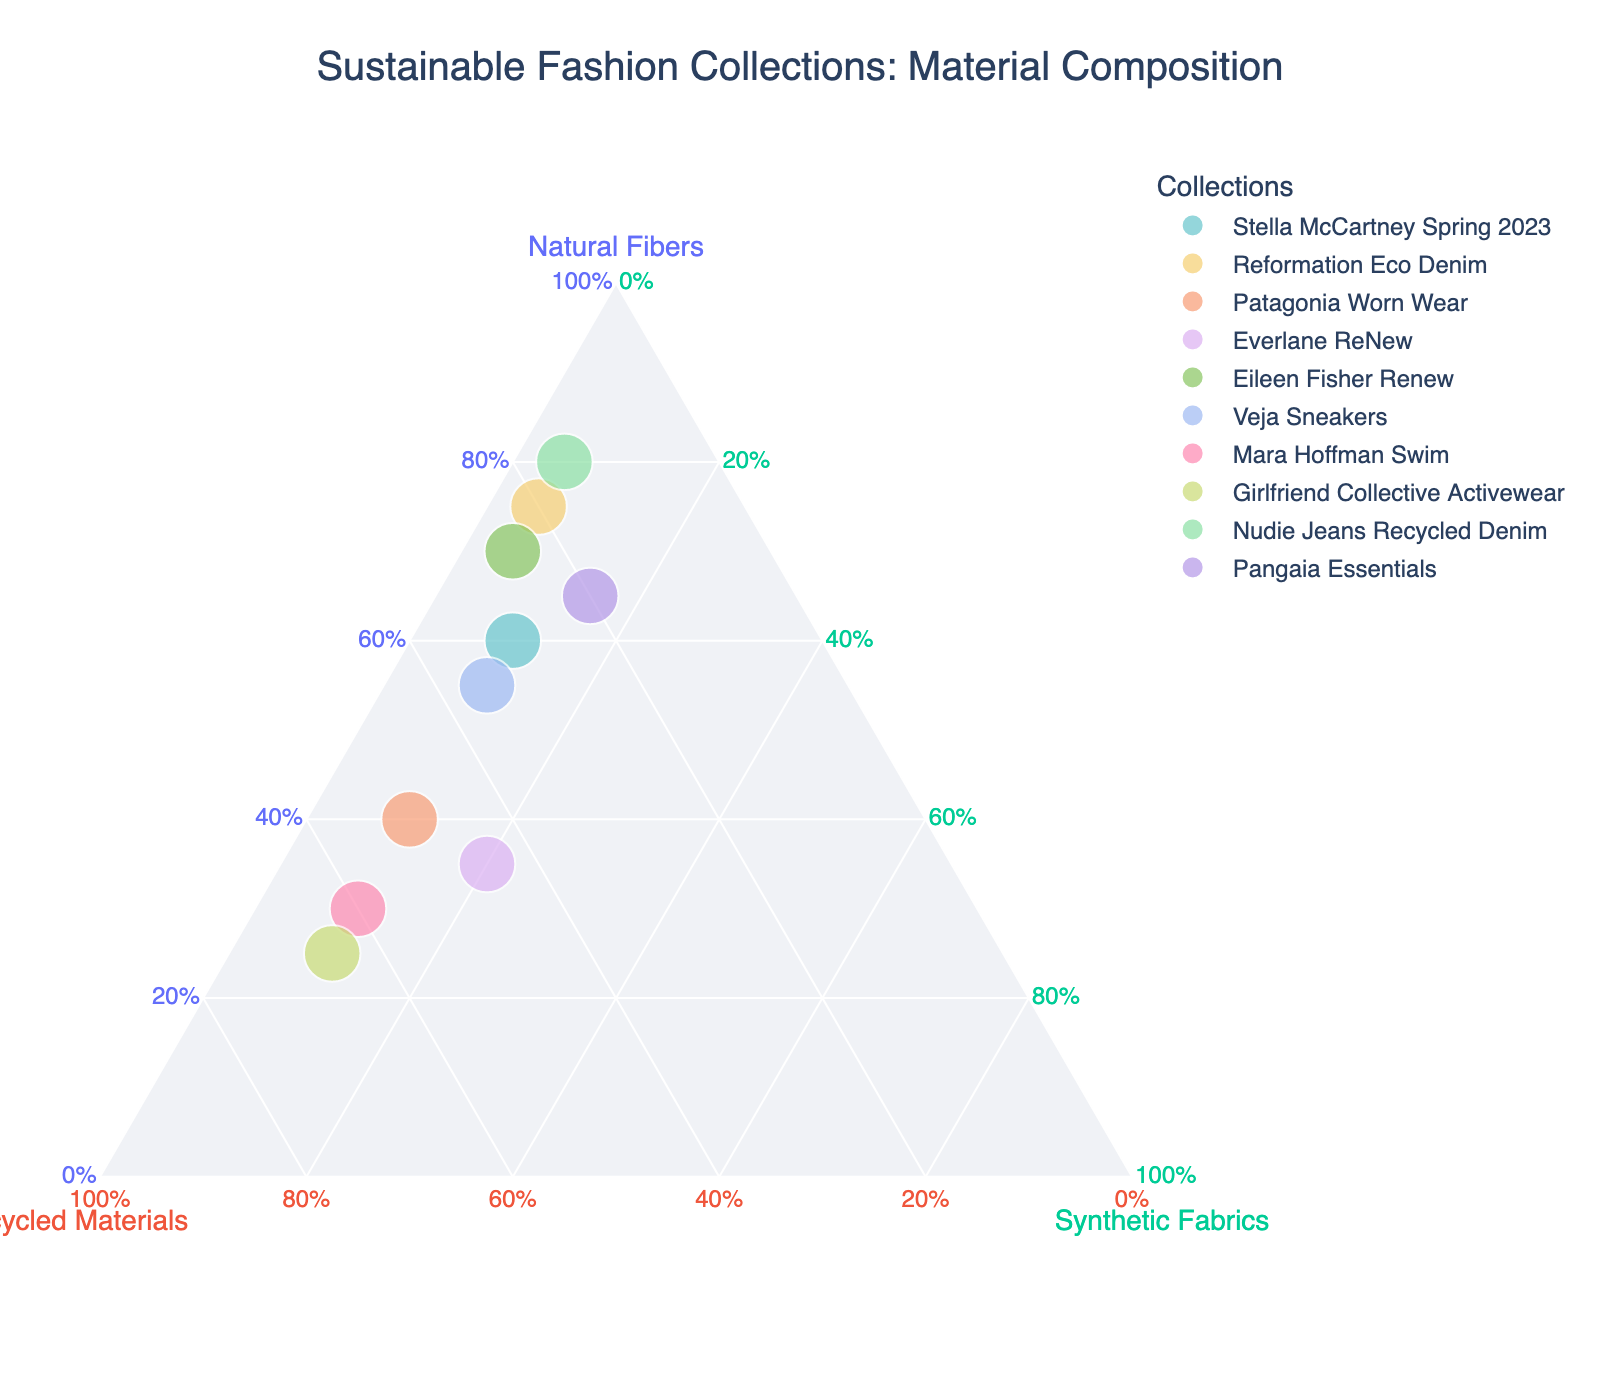What's the title of the figure? The title is usually at the top of the figure. In this case, it is "Sustainable Fashion Collections: Material Composition".
Answer: Sustainable Fashion Collections: Material Composition How many fashion collections are represented in the plot? Each data point represents a fashion collection. Counting the data points, we find there are 10 collections.
Answer: 10 Which collection uses the highest proportion of natural fibers? Look for the data point located closest to the "Natural Fibers" axis' vertex. That point corresponds to "Nudie Jeans Recycled Denim".
Answer: Nudie Jeans Recycled Denim Between "Veja Sneakers" and "Everlane ReNew," which collection has a higher proportion of recycled materials? Compare their positions along the "Recycled Materials" axis. "Veja Sneakers" (0.35) is higher in recycled materials than "Everlane ReNew" (0.45).
Answer: Everlane ReNew Which collection has the highest proportion of synthetic fabrics? Look for the point closest to the "Synthetic Fabrics" axis' vertex. "Pangaia Essentials" has 0.15, the highest proportion of synthetic fabrics in this chart.
Answer: Pangaia Essentials What is the combined proportion of natural fibers and recycled materials in "Reformation Eco Denim"? For "Reformation Eco Denim," sum the proportions of natural fibers (0.75) and recycled materials (0.20): 0.75 + 0.20 = 0.95.
Answer: 0.95 Which collection has an equal proportion of natural fibers and recycled materials? Only "Stella McCartney Spring 2023" has equal proportions for natural fibers (0.60) and recycled materials (0.30), where no collection has the exact match between natural fibers and recycled materials.
Answer: None How does "Patagonia Worn Wear" compare to "Stella McCartney Spring 2023" in terms of synthetic fabric usage? Compare their positions along the "Synthetic Fabrics" axis; both have the same proportion (0.10).
Answer: Equal Which two collections have the same proportion of synthetic fabrics? Find the points that are aligned vertically along the "Synthetic Fabrics" axis and have the same value at 0.10: "Stella McCartney Spring 2023," "Patagonia Worn Wear," "Veja Sneakers," "Mara Hoffman Swim," and "Girlfriend Collective Activewear".
Answer: Stella McCartney Spring 2023, Patagonia Worn Wear, Veja Sneakers, Mara Hoffman Swim, Girlfriend Collective Activewear 